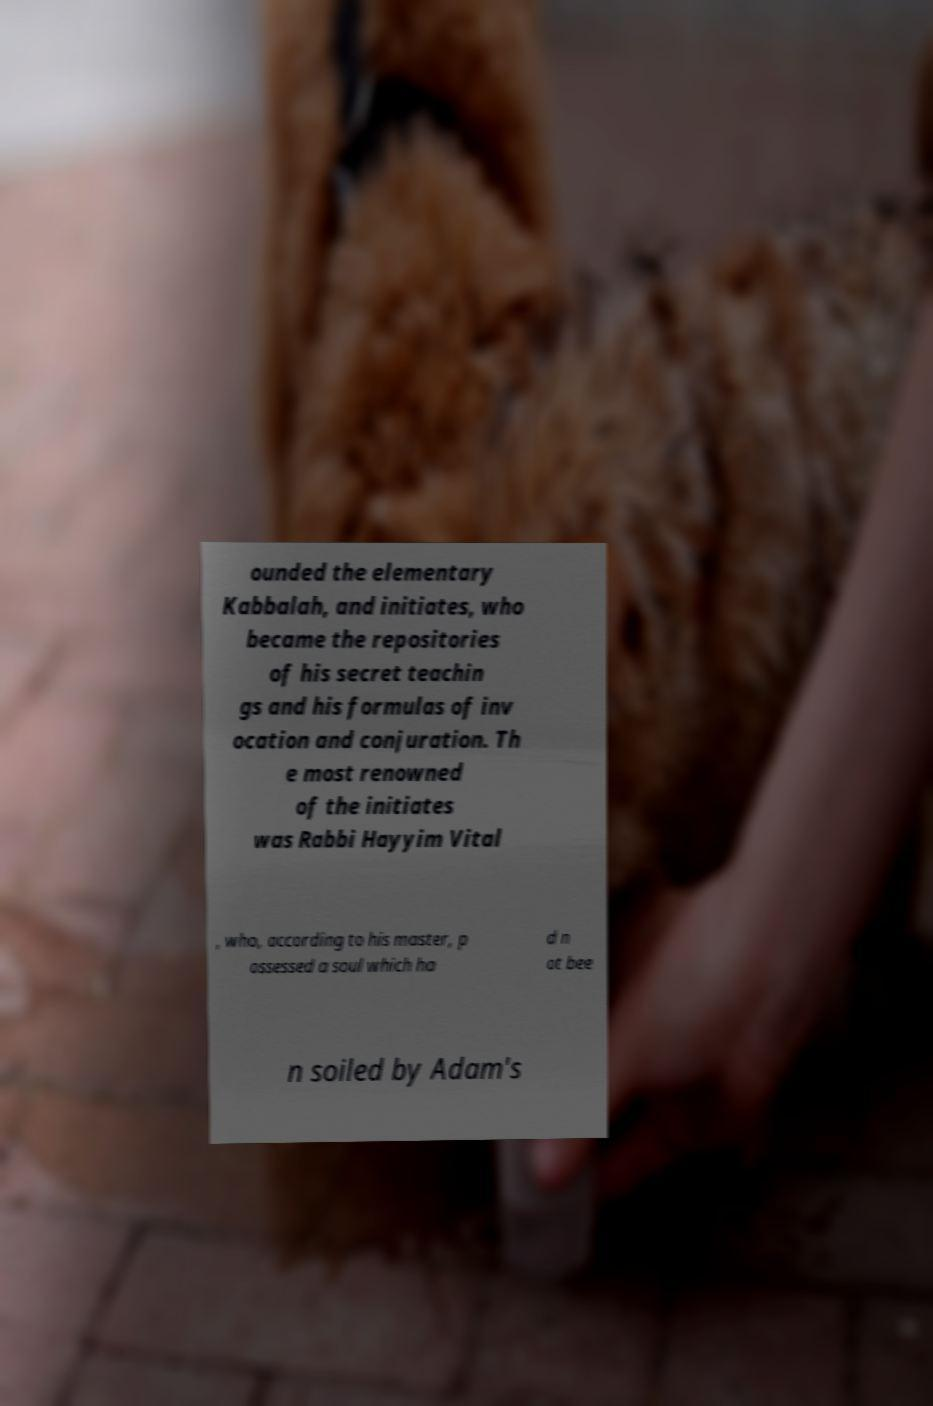Please read and relay the text visible in this image. What does it say? ounded the elementary Kabbalah, and initiates, who became the repositories of his secret teachin gs and his formulas of inv ocation and conjuration. Th e most renowned of the initiates was Rabbi Hayyim Vital , who, according to his master, p ossessed a soul which ha d n ot bee n soiled by Adam's 